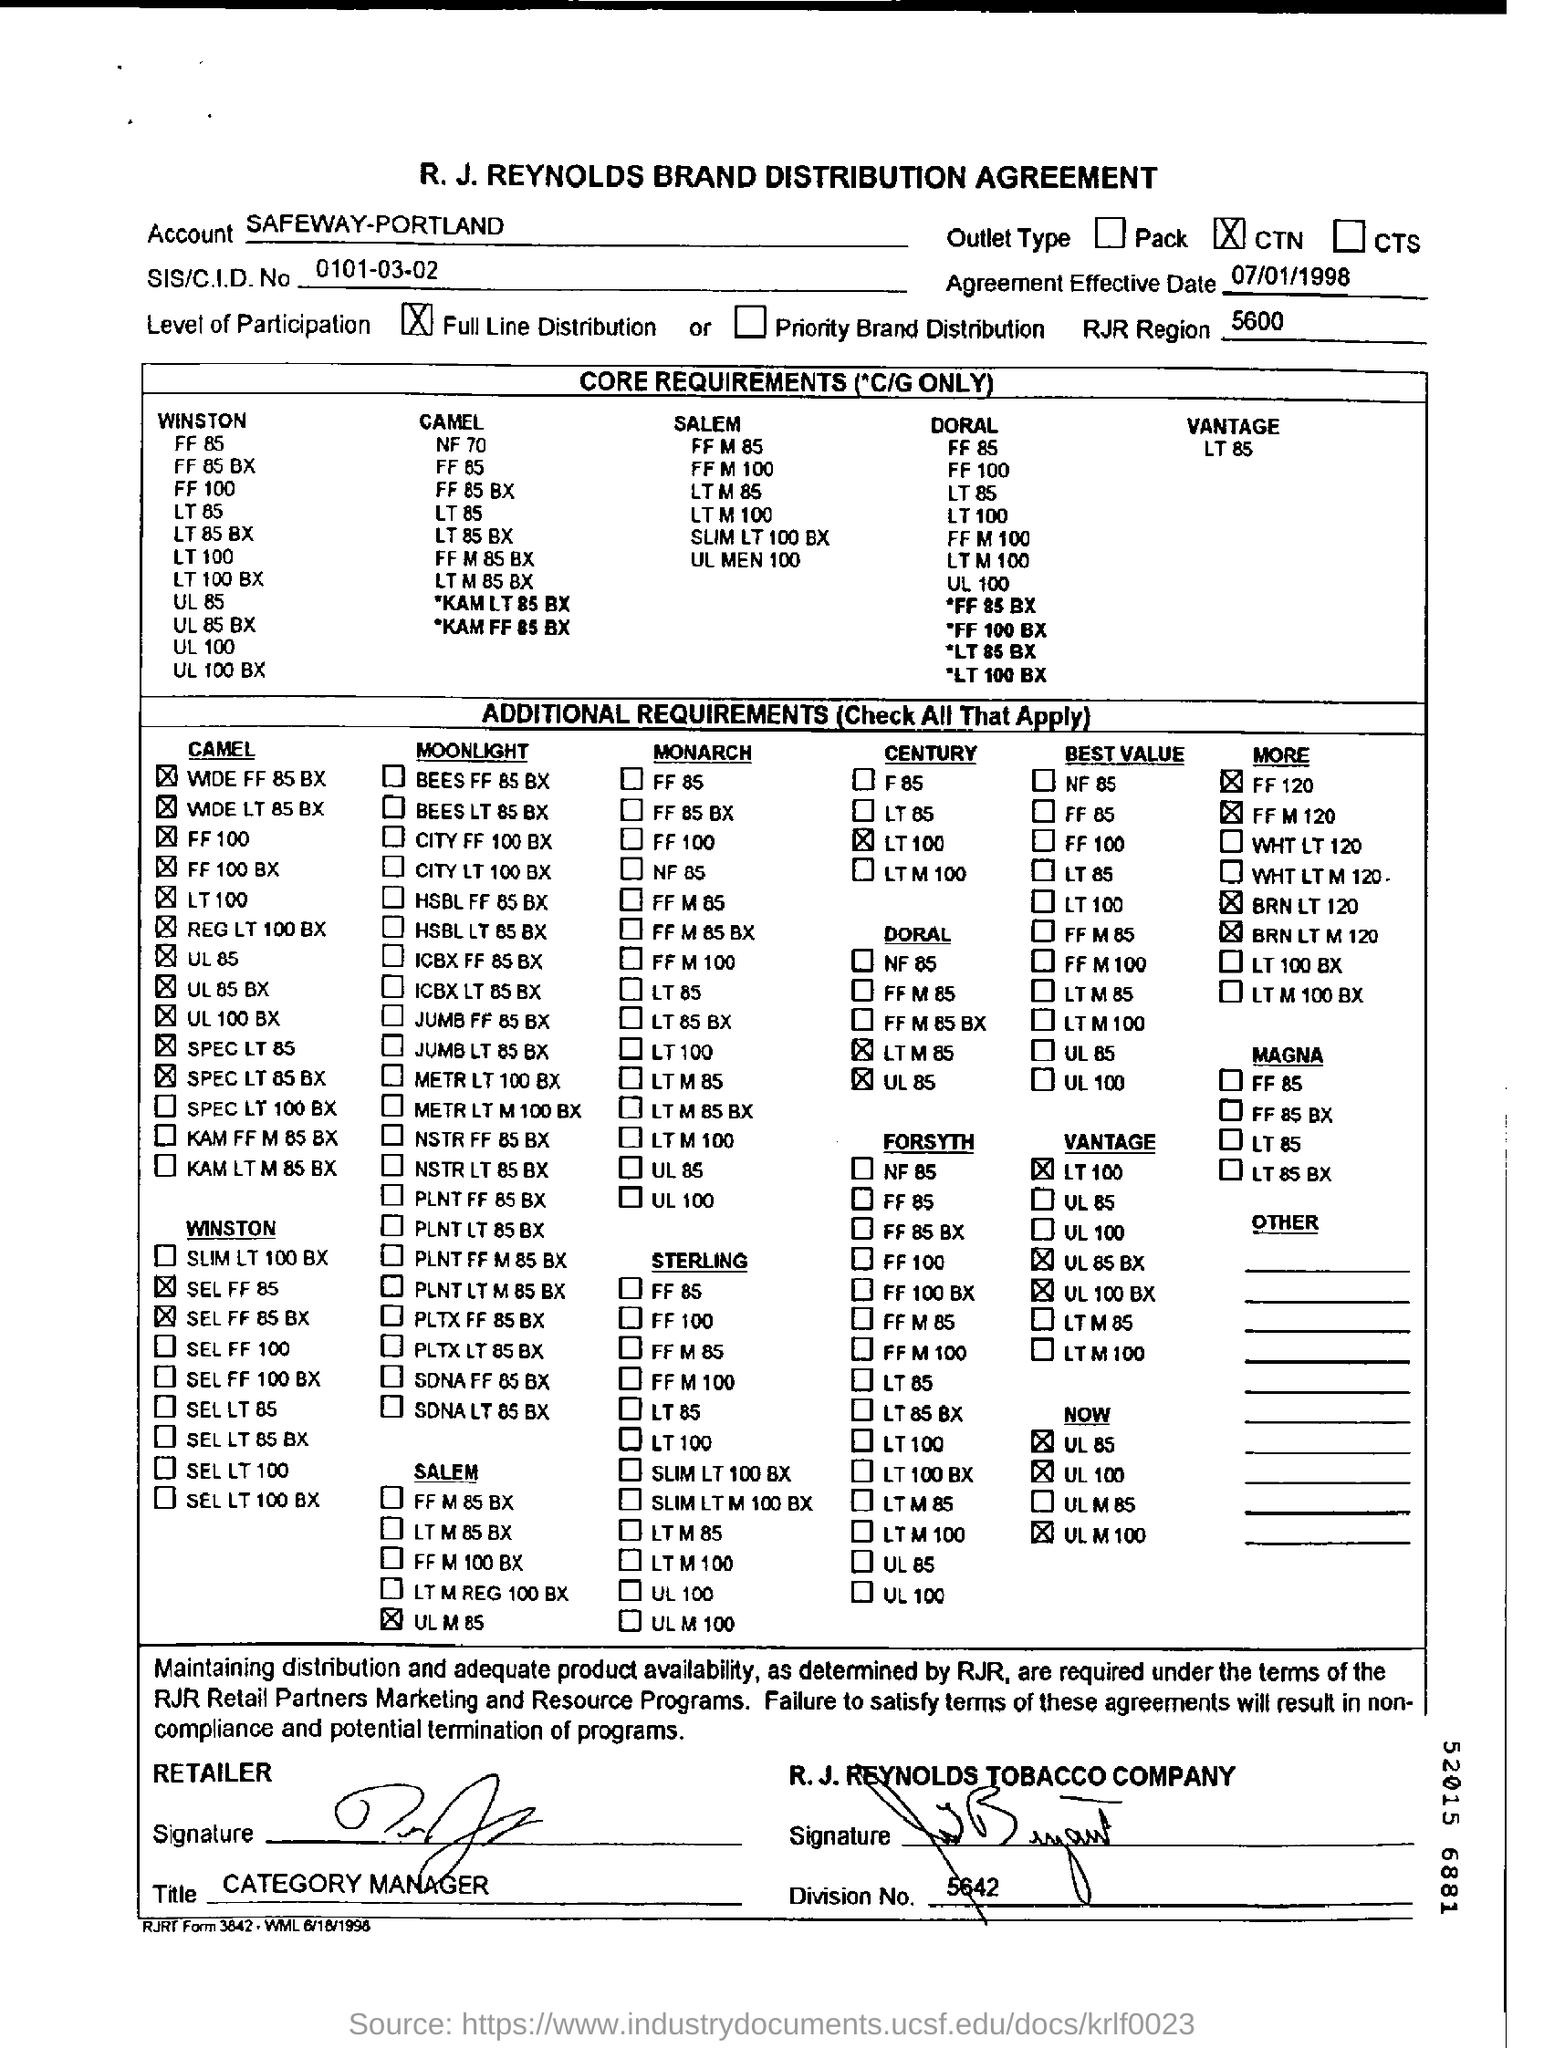What is the Agreement Effective Date ?
Offer a terse response. 07/01/1998. What is the Account name ?
Offer a terse response. SAFEWAY-PORTLAND. What is the title of the person who signed from Retailer Side ?
Your response must be concise. Category Manager. 